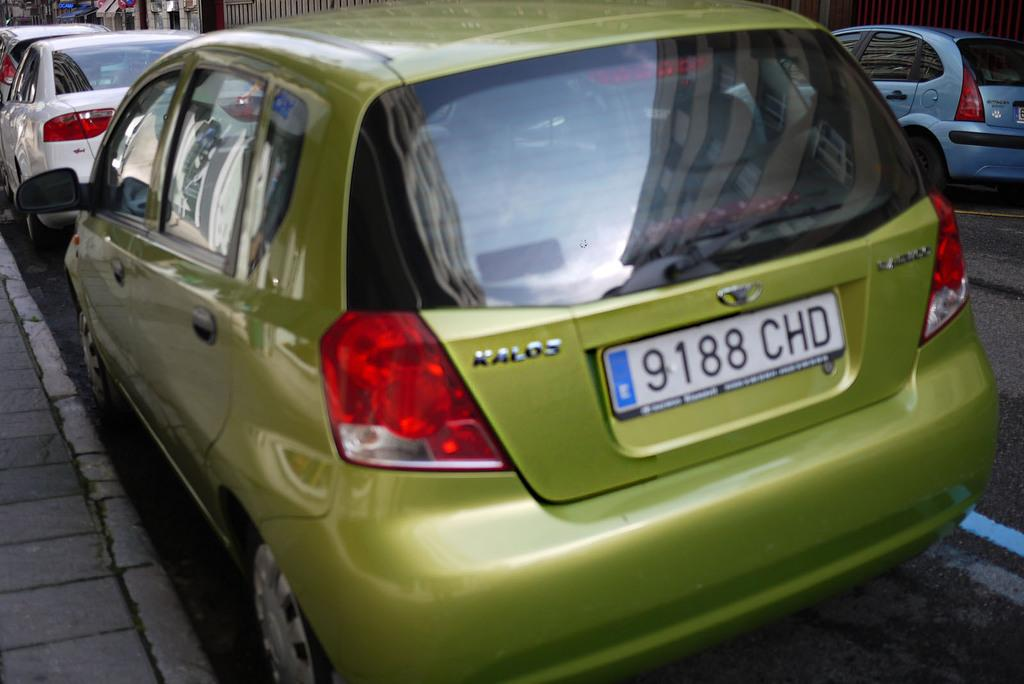What can be seen on the road in the image? There are vehicles on the road in the image. What structures can be seen in the background of the image? There are sheds visible in the background of the image. How many fingers can be seen on the jellyfish in the image? There are no jellyfish present in the image, so it is not possible to determine the number of fingers on a jellyfish. 